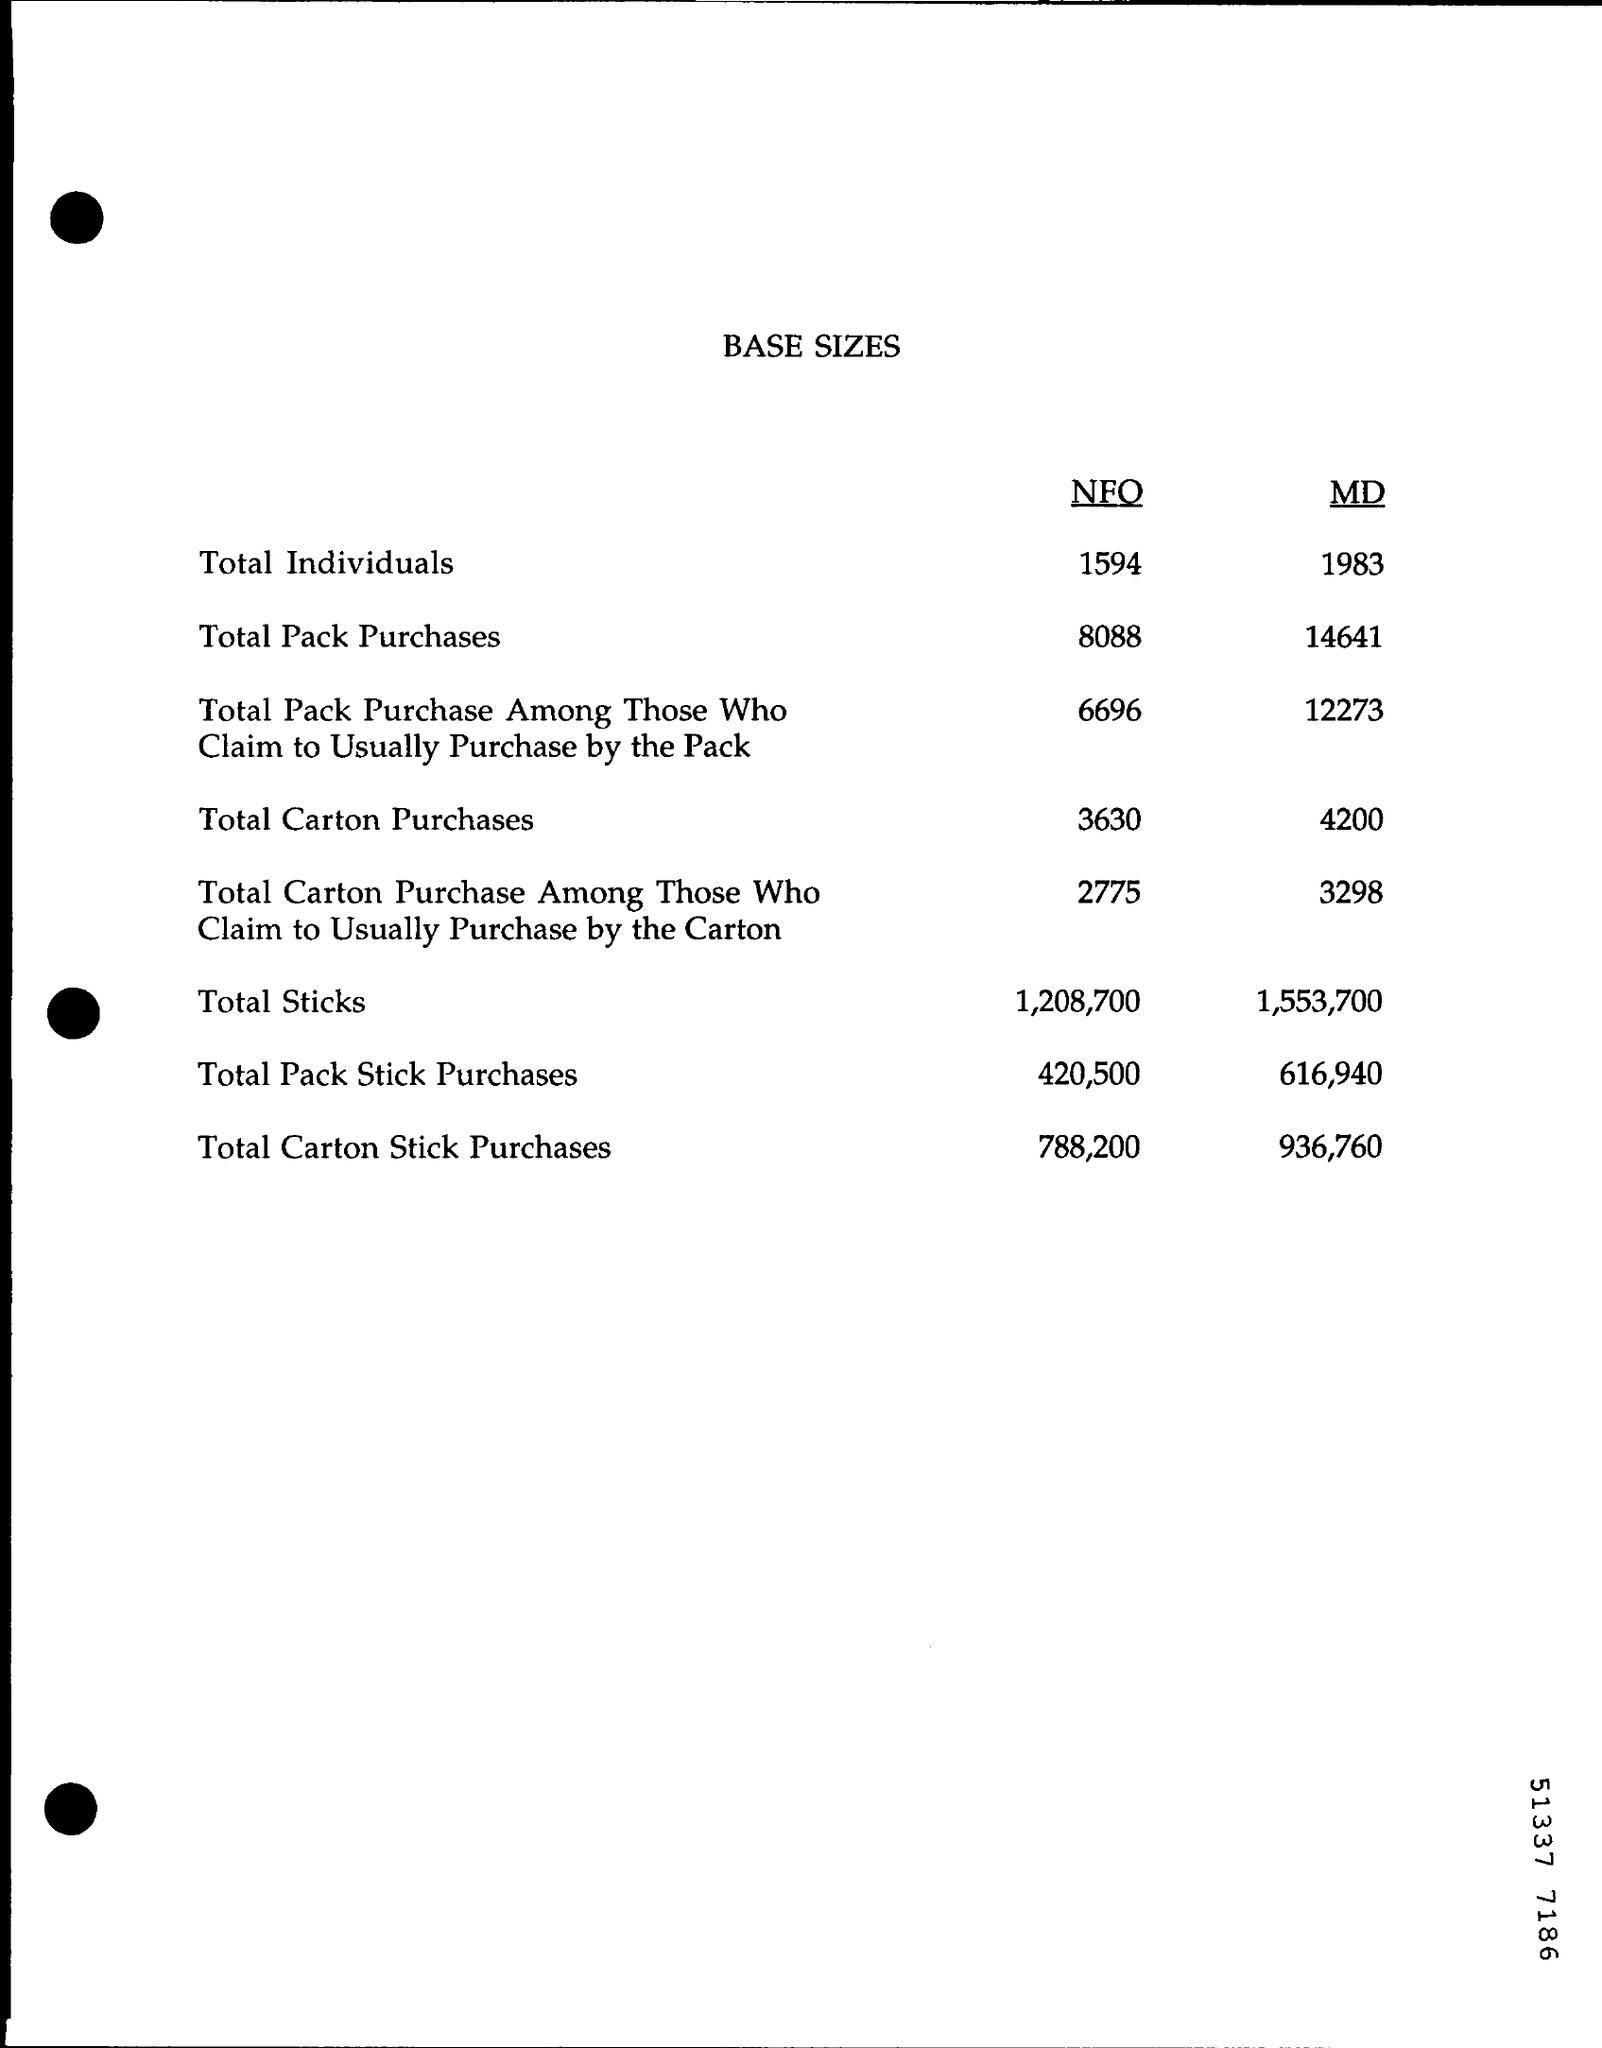Draw attention to some important aspects in this diagram. The total number of packs and sticks purchased under MD is 616,940. The title of the document is 'BASE SIZES.' What is the total amount of carton purchases under NFO? The exact amount is 3,630 cartons. 